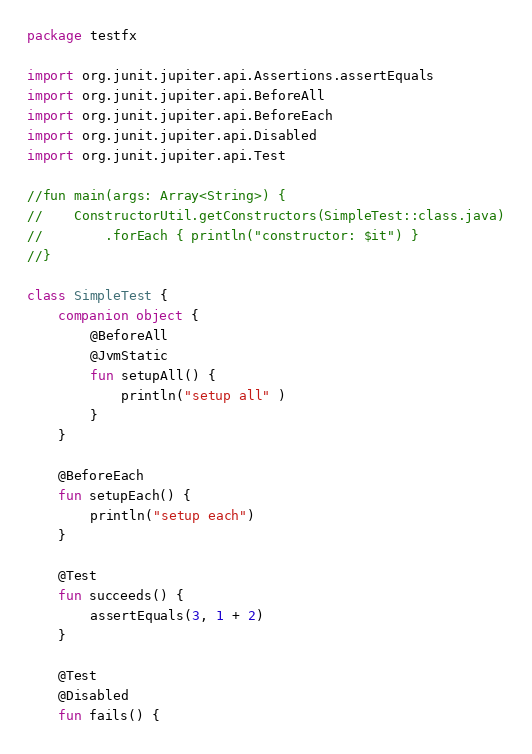Convert code to text. <code><loc_0><loc_0><loc_500><loc_500><_Kotlin_>package testfx

import org.junit.jupiter.api.Assertions.assertEquals
import org.junit.jupiter.api.BeforeAll
import org.junit.jupiter.api.BeforeEach
import org.junit.jupiter.api.Disabled
import org.junit.jupiter.api.Test

//fun main(args: Array<String>) {
//    ConstructorUtil.getConstructors(SimpleTest::class.java)
//        .forEach { println("constructor: $it") }
//}

class SimpleTest {
    companion object {
        @BeforeAll
        @JvmStatic
        fun setupAll() {
            println("setup all" )
        }
    }

    @BeforeEach
    fun setupEach() {
        println("setup each")
    }

    @Test
    fun succeeds() {
        assertEquals(3, 1 + 2)
    }

    @Test
    @Disabled
    fun fails() {</code> 